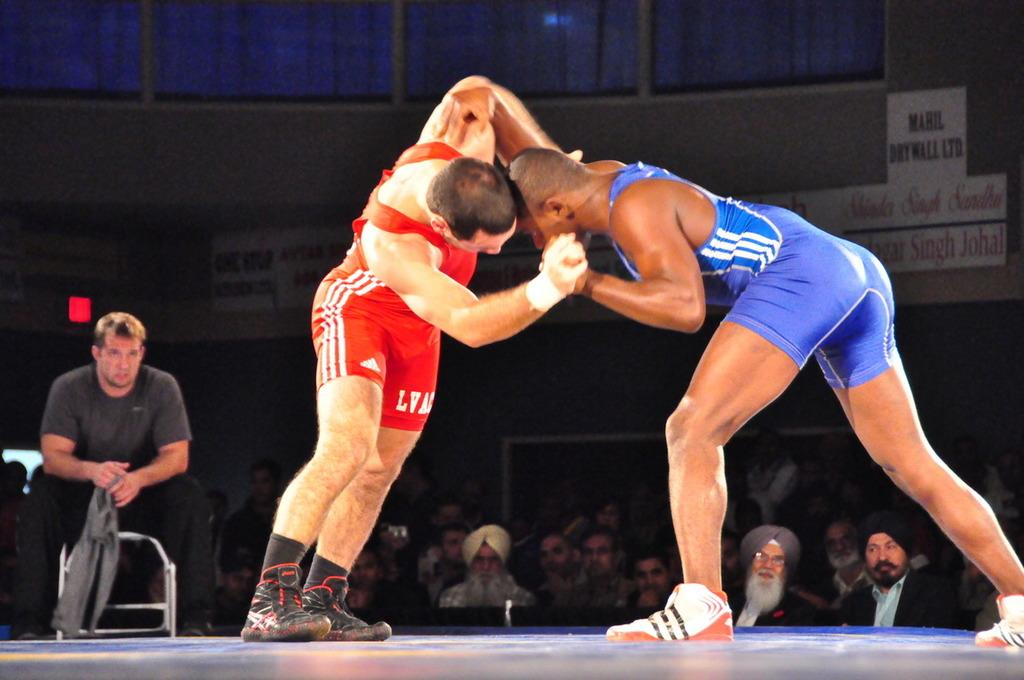<image>
Present a compact description of the photo's key features. A man with a red outfit that says "LVAC" is wrestling another man. 